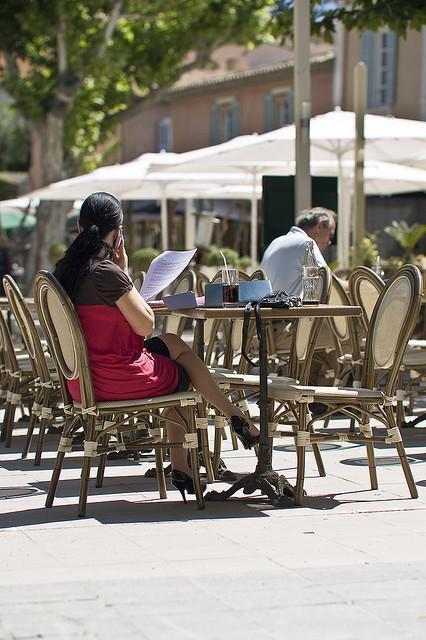How many people sit alone?
Give a very brief answer. 2. How many people are in the picture?
Give a very brief answer. 2. How many chairs are there?
Give a very brief answer. 7. How many umbrellas are in the photo?
Give a very brief answer. 2. 